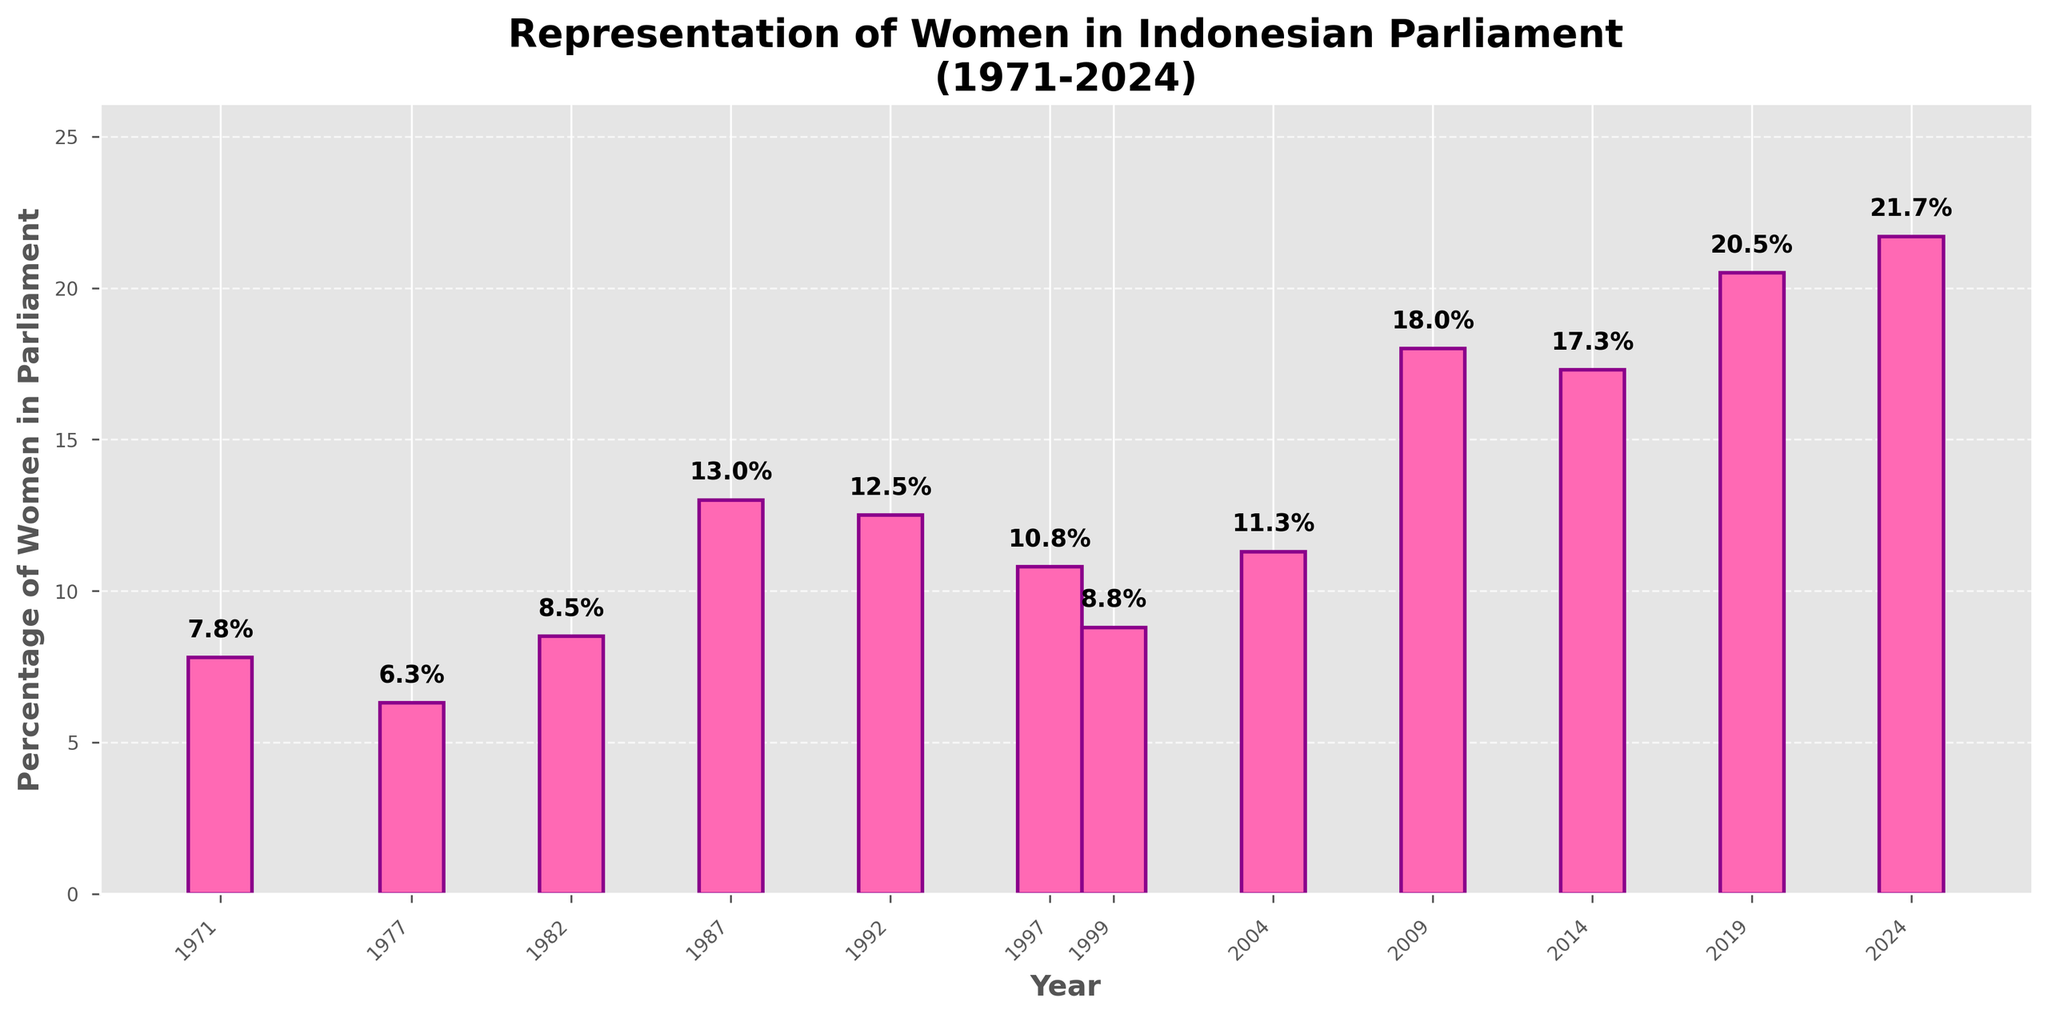What's the highest percentage of women in the Indonesian parliament over the past 50 years? Look at the tallest bar in the plot. The highest percentage value can be seen at the top of this bar, which corresponds to the value recorded in the year 2024.
Answer: 21.7% Which year had the lowest representation of women in the Indonesian parliament? Look at the shortest bar in the plot. Identify the year label below this shortest bar.
Answer: 1977 How much did the percentage of women in parliament increase from 2004 to 2009? Find the bar corresponding to the year 2004 and the bar for 2009. Subtract the percentage of 2004 (11.3%) from the percentage of 2009 (18.0%).
Answer: 6.7% Between which consecutive election years did the percentage of women in parliament increase the most? Compare the differences between the heights of consecutive bars. The largest difference in height between two consecutive bars indicates the greatest increase. This difference is from 2004 to 2009.
Answer: 2004 to 2009 What is the average percentage of women in Indonesian parliament from 1971 to 2024? Sum all the percentage values available in the dataset and divide by the number of observations (12 years). Sum = 7.8 + 6.3 + 8.5 + 13.0 + 12.5 + 10.8 + 8.8 + 11.3 + 18.0 + 17.3 + 20.5 + 21.7 = 156.5. So, the average is 156.5 / 12 = 13.04%.
Answer: 13.04% How does the percentage of women in parliament in 2019 compare with that in 1971? Identify the percentages for the years 2019 and 1971 from the bars. In 2019, the percentage is 20.5% and in 1971, it is 7.8%. Since 20.5% is greater than 7.8%, the percentage increased.
Answer: Increased By how much did the percentage of women in parliament decrease from 1987 to 1992? Subtract the percentage in 1992 (12.5%) from 1987 (13.0%).
Answer: 0.5% What trend can be observed in the representation of women in Indonesian parliament from 1997 to 2024? Analyze the heights of the bars sequentially from 1997 to 2024. The trend appears to be an overall increase with some fluctuations.
Answer: Increasing trend What can you infer about the representation of women in Indonesian parliament before and after the year 2000? Compare the heights of the bars before and after the year 2000. Before 2000, the bars show lower percentages, and after 2000, we observe a more notable increase with overall higher percentages.
Answer: Increased representation 